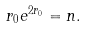<formula> <loc_0><loc_0><loc_500><loc_500>r _ { 0 } e ^ { 2 r _ { 0 } } = n .</formula> 